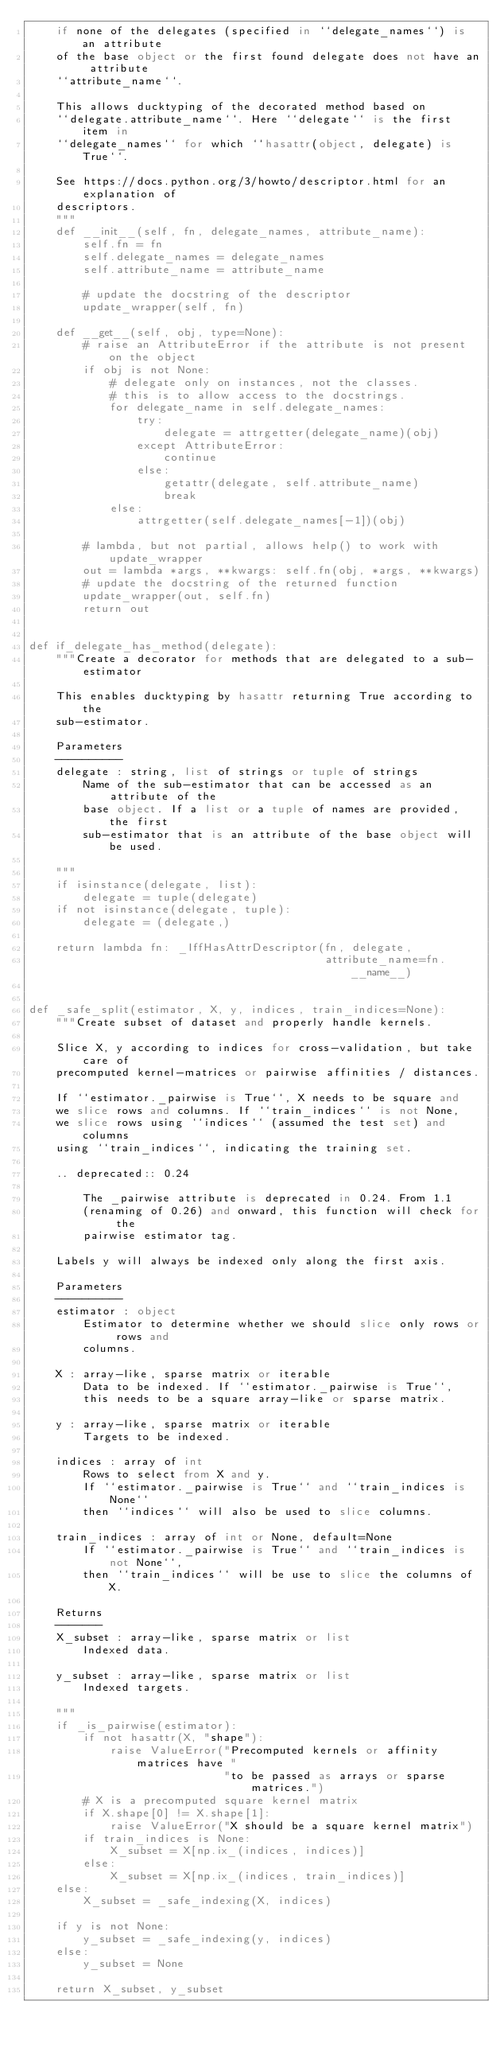Convert code to text. <code><loc_0><loc_0><loc_500><loc_500><_Python_>    if none of the delegates (specified in ``delegate_names``) is an attribute
    of the base object or the first found delegate does not have an attribute
    ``attribute_name``.

    This allows ducktyping of the decorated method based on
    ``delegate.attribute_name``. Here ``delegate`` is the first item in
    ``delegate_names`` for which ``hasattr(object, delegate) is True``.

    See https://docs.python.org/3/howto/descriptor.html for an explanation of
    descriptors.
    """
    def __init__(self, fn, delegate_names, attribute_name):
        self.fn = fn
        self.delegate_names = delegate_names
        self.attribute_name = attribute_name

        # update the docstring of the descriptor
        update_wrapper(self, fn)

    def __get__(self, obj, type=None):
        # raise an AttributeError if the attribute is not present on the object
        if obj is not None:
            # delegate only on instances, not the classes.
            # this is to allow access to the docstrings.
            for delegate_name in self.delegate_names:
                try:
                    delegate = attrgetter(delegate_name)(obj)
                except AttributeError:
                    continue
                else:
                    getattr(delegate, self.attribute_name)
                    break
            else:
                attrgetter(self.delegate_names[-1])(obj)

        # lambda, but not partial, allows help() to work with update_wrapper
        out = lambda *args, **kwargs: self.fn(obj, *args, **kwargs)
        # update the docstring of the returned function
        update_wrapper(out, self.fn)
        return out


def if_delegate_has_method(delegate):
    """Create a decorator for methods that are delegated to a sub-estimator

    This enables ducktyping by hasattr returning True according to the
    sub-estimator.

    Parameters
    ----------
    delegate : string, list of strings or tuple of strings
        Name of the sub-estimator that can be accessed as an attribute of the
        base object. If a list or a tuple of names are provided, the first
        sub-estimator that is an attribute of the base object will be used.

    """
    if isinstance(delegate, list):
        delegate = tuple(delegate)
    if not isinstance(delegate, tuple):
        delegate = (delegate,)

    return lambda fn: _IffHasAttrDescriptor(fn, delegate,
                                            attribute_name=fn.__name__)


def _safe_split(estimator, X, y, indices, train_indices=None):
    """Create subset of dataset and properly handle kernels.

    Slice X, y according to indices for cross-validation, but take care of
    precomputed kernel-matrices or pairwise affinities / distances.

    If ``estimator._pairwise is True``, X needs to be square and
    we slice rows and columns. If ``train_indices`` is not None,
    we slice rows using ``indices`` (assumed the test set) and columns
    using ``train_indices``, indicating the training set.

    .. deprecated:: 0.24

        The _pairwise attribute is deprecated in 0.24. From 1.1
        (renaming of 0.26) and onward, this function will check for the
        pairwise estimator tag.

    Labels y will always be indexed only along the first axis.

    Parameters
    ----------
    estimator : object
        Estimator to determine whether we should slice only rows or rows and
        columns.

    X : array-like, sparse matrix or iterable
        Data to be indexed. If ``estimator._pairwise is True``,
        this needs to be a square array-like or sparse matrix.

    y : array-like, sparse matrix or iterable
        Targets to be indexed.

    indices : array of int
        Rows to select from X and y.
        If ``estimator._pairwise is True`` and ``train_indices is None``
        then ``indices`` will also be used to slice columns.

    train_indices : array of int or None, default=None
        If ``estimator._pairwise is True`` and ``train_indices is not None``,
        then ``train_indices`` will be use to slice the columns of X.

    Returns
    -------
    X_subset : array-like, sparse matrix or list
        Indexed data.

    y_subset : array-like, sparse matrix or list
        Indexed targets.

    """
    if _is_pairwise(estimator):
        if not hasattr(X, "shape"):
            raise ValueError("Precomputed kernels or affinity matrices have "
                             "to be passed as arrays or sparse matrices.")
        # X is a precomputed square kernel matrix
        if X.shape[0] != X.shape[1]:
            raise ValueError("X should be a square kernel matrix")
        if train_indices is None:
            X_subset = X[np.ix_(indices, indices)]
        else:
            X_subset = X[np.ix_(indices, train_indices)]
    else:
        X_subset = _safe_indexing(X, indices)

    if y is not None:
        y_subset = _safe_indexing(y, indices)
    else:
        y_subset = None

    return X_subset, y_subset
</code> 